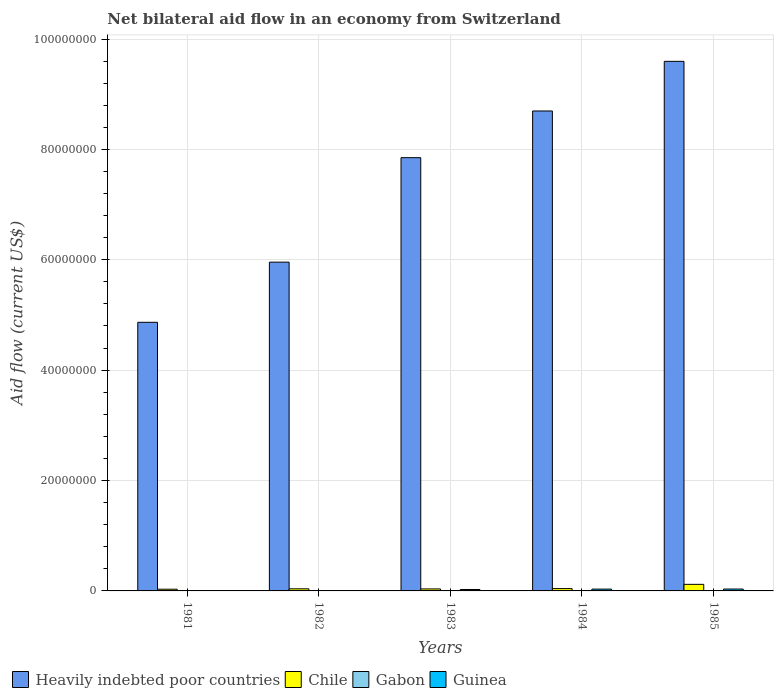How many different coloured bars are there?
Make the answer very short. 4. How many groups of bars are there?
Your answer should be very brief. 5. Are the number of bars on each tick of the X-axis equal?
Make the answer very short. Yes. How many bars are there on the 2nd tick from the left?
Provide a succinct answer. 4. How many bars are there on the 4th tick from the right?
Make the answer very short. 4. What is the label of the 3rd group of bars from the left?
Your answer should be compact. 1983. What is the net bilateral aid flow in Heavily indebted poor countries in 1984?
Give a very brief answer. 8.70e+07. Across all years, what is the maximum net bilateral aid flow in Chile?
Provide a short and direct response. 1.19e+06. Across all years, what is the minimum net bilateral aid flow in Gabon?
Your answer should be very brief. 10000. In which year was the net bilateral aid flow in Heavily indebted poor countries minimum?
Keep it short and to the point. 1981. What is the difference between the net bilateral aid flow in Heavily indebted poor countries in 1984 and that in 1985?
Your answer should be very brief. -8.99e+06. What is the difference between the net bilateral aid flow in Guinea in 1983 and the net bilateral aid flow in Chile in 1985?
Your answer should be very brief. -9.30e+05. What is the average net bilateral aid flow in Guinea per year?
Offer a very short reply. 2.00e+05. In how many years, is the net bilateral aid flow in Guinea greater than 72000000 US$?
Offer a terse response. 0. What is the ratio of the net bilateral aid flow in Guinea in 1982 to that in 1985?
Your answer should be very brief. 0.18. Is the net bilateral aid flow in Heavily indebted poor countries in 1984 less than that in 1985?
Give a very brief answer. Yes. What is the difference between the highest and the second highest net bilateral aid flow in Heavily indebted poor countries?
Give a very brief answer. 8.99e+06. What is the difference between the highest and the lowest net bilateral aid flow in Chile?
Keep it short and to the point. 8.80e+05. In how many years, is the net bilateral aid flow in Gabon greater than the average net bilateral aid flow in Gabon taken over all years?
Your response must be concise. 4. What does the 1st bar from the left in 1981 represents?
Your response must be concise. Heavily indebted poor countries. What does the 4th bar from the right in 1982 represents?
Ensure brevity in your answer.  Heavily indebted poor countries. How many bars are there?
Provide a short and direct response. 20. What is the difference between two consecutive major ticks on the Y-axis?
Ensure brevity in your answer.  2.00e+07. How many legend labels are there?
Offer a very short reply. 4. What is the title of the graph?
Offer a terse response. Net bilateral aid flow in an economy from Switzerland. Does "Estonia" appear as one of the legend labels in the graph?
Keep it short and to the point. No. What is the label or title of the X-axis?
Provide a short and direct response. Years. What is the label or title of the Y-axis?
Keep it short and to the point. Aid flow (current US$). What is the Aid flow (current US$) in Heavily indebted poor countries in 1981?
Provide a succinct answer. 4.87e+07. What is the Aid flow (current US$) in Heavily indebted poor countries in 1982?
Make the answer very short. 5.96e+07. What is the Aid flow (current US$) in Chile in 1982?
Your answer should be very brief. 3.80e+05. What is the Aid flow (current US$) of Heavily indebted poor countries in 1983?
Your answer should be compact. 7.85e+07. What is the Aid flow (current US$) in Chile in 1983?
Your answer should be very brief. 3.60e+05. What is the Aid flow (current US$) of Guinea in 1983?
Offer a very short reply. 2.60e+05. What is the Aid flow (current US$) in Heavily indebted poor countries in 1984?
Provide a short and direct response. 8.70e+07. What is the Aid flow (current US$) in Chile in 1984?
Keep it short and to the point. 4.20e+05. What is the Aid flow (current US$) in Guinea in 1984?
Give a very brief answer. 3.30e+05. What is the Aid flow (current US$) in Heavily indebted poor countries in 1985?
Your answer should be compact. 9.60e+07. What is the Aid flow (current US$) of Chile in 1985?
Ensure brevity in your answer.  1.19e+06. Across all years, what is the maximum Aid flow (current US$) of Heavily indebted poor countries?
Your answer should be very brief. 9.60e+07. Across all years, what is the maximum Aid flow (current US$) of Chile?
Offer a very short reply. 1.19e+06. Across all years, what is the minimum Aid flow (current US$) in Heavily indebted poor countries?
Make the answer very short. 4.87e+07. Across all years, what is the minimum Aid flow (current US$) in Chile?
Offer a very short reply. 3.10e+05. What is the total Aid flow (current US$) in Heavily indebted poor countries in the graph?
Keep it short and to the point. 3.70e+08. What is the total Aid flow (current US$) in Chile in the graph?
Give a very brief answer. 2.66e+06. What is the total Aid flow (current US$) of Guinea in the graph?
Keep it short and to the point. 1.00e+06. What is the difference between the Aid flow (current US$) of Heavily indebted poor countries in 1981 and that in 1982?
Offer a very short reply. -1.09e+07. What is the difference between the Aid flow (current US$) in Gabon in 1981 and that in 1982?
Offer a very short reply. -4.00e+04. What is the difference between the Aid flow (current US$) of Heavily indebted poor countries in 1981 and that in 1983?
Your response must be concise. -2.98e+07. What is the difference between the Aid flow (current US$) of Chile in 1981 and that in 1983?
Make the answer very short. -5.00e+04. What is the difference between the Aid flow (current US$) in Gabon in 1981 and that in 1983?
Offer a terse response. -5.00e+04. What is the difference between the Aid flow (current US$) of Guinea in 1981 and that in 1983?
Ensure brevity in your answer.  -2.50e+05. What is the difference between the Aid flow (current US$) of Heavily indebted poor countries in 1981 and that in 1984?
Your response must be concise. -3.83e+07. What is the difference between the Aid flow (current US$) in Chile in 1981 and that in 1984?
Provide a short and direct response. -1.10e+05. What is the difference between the Aid flow (current US$) in Gabon in 1981 and that in 1984?
Provide a succinct answer. -4.00e+04. What is the difference between the Aid flow (current US$) of Guinea in 1981 and that in 1984?
Offer a terse response. -3.20e+05. What is the difference between the Aid flow (current US$) of Heavily indebted poor countries in 1981 and that in 1985?
Offer a very short reply. -4.73e+07. What is the difference between the Aid flow (current US$) in Chile in 1981 and that in 1985?
Your answer should be compact. -8.80e+05. What is the difference between the Aid flow (current US$) in Guinea in 1981 and that in 1985?
Your answer should be compact. -3.30e+05. What is the difference between the Aid flow (current US$) of Heavily indebted poor countries in 1982 and that in 1983?
Ensure brevity in your answer.  -1.89e+07. What is the difference between the Aid flow (current US$) of Gabon in 1982 and that in 1983?
Provide a succinct answer. -10000. What is the difference between the Aid flow (current US$) of Guinea in 1982 and that in 1983?
Make the answer very short. -2.00e+05. What is the difference between the Aid flow (current US$) in Heavily indebted poor countries in 1982 and that in 1984?
Ensure brevity in your answer.  -2.74e+07. What is the difference between the Aid flow (current US$) of Guinea in 1982 and that in 1984?
Your answer should be compact. -2.70e+05. What is the difference between the Aid flow (current US$) of Heavily indebted poor countries in 1982 and that in 1985?
Provide a short and direct response. -3.64e+07. What is the difference between the Aid flow (current US$) in Chile in 1982 and that in 1985?
Provide a short and direct response. -8.10e+05. What is the difference between the Aid flow (current US$) of Gabon in 1982 and that in 1985?
Ensure brevity in your answer.  -10000. What is the difference between the Aid flow (current US$) of Guinea in 1982 and that in 1985?
Make the answer very short. -2.80e+05. What is the difference between the Aid flow (current US$) of Heavily indebted poor countries in 1983 and that in 1984?
Give a very brief answer. -8.46e+06. What is the difference between the Aid flow (current US$) of Chile in 1983 and that in 1984?
Ensure brevity in your answer.  -6.00e+04. What is the difference between the Aid flow (current US$) in Guinea in 1983 and that in 1984?
Provide a succinct answer. -7.00e+04. What is the difference between the Aid flow (current US$) in Heavily indebted poor countries in 1983 and that in 1985?
Your answer should be very brief. -1.74e+07. What is the difference between the Aid flow (current US$) in Chile in 1983 and that in 1985?
Your answer should be very brief. -8.30e+05. What is the difference between the Aid flow (current US$) of Gabon in 1983 and that in 1985?
Your answer should be very brief. 0. What is the difference between the Aid flow (current US$) in Guinea in 1983 and that in 1985?
Give a very brief answer. -8.00e+04. What is the difference between the Aid flow (current US$) in Heavily indebted poor countries in 1984 and that in 1985?
Give a very brief answer. -8.99e+06. What is the difference between the Aid flow (current US$) in Chile in 1984 and that in 1985?
Provide a succinct answer. -7.70e+05. What is the difference between the Aid flow (current US$) of Gabon in 1984 and that in 1985?
Your answer should be very brief. -10000. What is the difference between the Aid flow (current US$) in Heavily indebted poor countries in 1981 and the Aid flow (current US$) in Chile in 1982?
Your answer should be very brief. 4.83e+07. What is the difference between the Aid flow (current US$) in Heavily indebted poor countries in 1981 and the Aid flow (current US$) in Gabon in 1982?
Offer a terse response. 4.86e+07. What is the difference between the Aid flow (current US$) of Heavily indebted poor countries in 1981 and the Aid flow (current US$) of Guinea in 1982?
Your response must be concise. 4.86e+07. What is the difference between the Aid flow (current US$) of Chile in 1981 and the Aid flow (current US$) of Guinea in 1982?
Offer a very short reply. 2.50e+05. What is the difference between the Aid flow (current US$) of Gabon in 1981 and the Aid flow (current US$) of Guinea in 1982?
Your answer should be very brief. -5.00e+04. What is the difference between the Aid flow (current US$) of Heavily indebted poor countries in 1981 and the Aid flow (current US$) of Chile in 1983?
Your response must be concise. 4.83e+07. What is the difference between the Aid flow (current US$) in Heavily indebted poor countries in 1981 and the Aid flow (current US$) in Gabon in 1983?
Ensure brevity in your answer.  4.86e+07. What is the difference between the Aid flow (current US$) of Heavily indebted poor countries in 1981 and the Aid flow (current US$) of Guinea in 1983?
Give a very brief answer. 4.84e+07. What is the difference between the Aid flow (current US$) of Chile in 1981 and the Aid flow (current US$) of Gabon in 1983?
Your answer should be compact. 2.50e+05. What is the difference between the Aid flow (current US$) of Heavily indebted poor countries in 1981 and the Aid flow (current US$) of Chile in 1984?
Make the answer very short. 4.82e+07. What is the difference between the Aid flow (current US$) in Heavily indebted poor countries in 1981 and the Aid flow (current US$) in Gabon in 1984?
Offer a very short reply. 4.86e+07. What is the difference between the Aid flow (current US$) in Heavily indebted poor countries in 1981 and the Aid flow (current US$) in Guinea in 1984?
Offer a terse response. 4.83e+07. What is the difference between the Aid flow (current US$) of Chile in 1981 and the Aid flow (current US$) of Guinea in 1984?
Give a very brief answer. -2.00e+04. What is the difference between the Aid flow (current US$) in Gabon in 1981 and the Aid flow (current US$) in Guinea in 1984?
Keep it short and to the point. -3.20e+05. What is the difference between the Aid flow (current US$) in Heavily indebted poor countries in 1981 and the Aid flow (current US$) in Chile in 1985?
Your answer should be very brief. 4.75e+07. What is the difference between the Aid flow (current US$) of Heavily indebted poor countries in 1981 and the Aid flow (current US$) of Gabon in 1985?
Offer a very short reply. 4.86e+07. What is the difference between the Aid flow (current US$) in Heavily indebted poor countries in 1981 and the Aid flow (current US$) in Guinea in 1985?
Make the answer very short. 4.83e+07. What is the difference between the Aid flow (current US$) in Gabon in 1981 and the Aid flow (current US$) in Guinea in 1985?
Keep it short and to the point. -3.30e+05. What is the difference between the Aid flow (current US$) of Heavily indebted poor countries in 1982 and the Aid flow (current US$) of Chile in 1983?
Ensure brevity in your answer.  5.92e+07. What is the difference between the Aid flow (current US$) of Heavily indebted poor countries in 1982 and the Aid flow (current US$) of Gabon in 1983?
Keep it short and to the point. 5.95e+07. What is the difference between the Aid flow (current US$) of Heavily indebted poor countries in 1982 and the Aid flow (current US$) of Guinea in 1983?
Offer a very short reply. 5.93e+07. What is the difference between the Aid flow (current US$) of Chile in 1982 and the Aid flow (current US$) of Guinea in 1983?
Provide a short and direct response. 1.20e+05. What is the difference between the Aid flow (current US$) of Gabon in 1982 and the Aid flow (current US$) of Guinea in 1983?
Keep it short and to the point. -2.10e+05. What is the difference between the Aid flow (current US$) in Heavily indebted poor countries in 1982 and the Aid flow (current US$) in Chile in 1984?
Your response must be concise. 5.92e+07. What is the difference between the Aid flow (current US$) of Heavily indebted poor countries in 1982 and the Aid flow (current US$) of Gabon in 1984?
Provide a short and direct response. 5.95e+07. What is the difference between the Aid flow (current US$) of Heavily indebted poor countries in 1982 and the Aid flow (current US$) of Guinea in 1984?
Offer a terse response. 5.92e+07. What is the difference between the Aid flow (current US$) of Chile in 1982 and the Aid flow (current US$) of Guinea in 1984?
Provide a short and direct response. 5.00e+04. What is the difference between the Aid flow (current US$) of Gabon in 1982 and the Aid flow (current US$) of Guinea in 1984?
Keep it short and to the point. -2.80e+05. What is the difference between the Aid flow (current US$) in Heavily indebted poor countries in 1982 and the Aid flow (current US$) in Chile in 1985?
Make the answer very short. 5.84e+07. What is the difference between the Aid flow (current US$) of Heavily indebted poor countries in 1982 and the Aid flow (current US$) of Gabon in 1985?
Make the answer very short. 5.95e+07. What is the difference between the Aid flow (current US$) of Heavily indebted poor countries in 1982 and the Aid flow (current US$) of Guinea in 1985?
Ensure brevity in your answer.  5.92e+07. What is the difference between the Aid flow (current US$) in Chile in 1982 and the Aid flow (current US$) in Guinea in 1985?
Offer a very short reply. 4.00e+04. What is the difference between the Aid flow (current US$) of Heavily indebted poor countries in 1983 and the Aid flow (current US$) of Chile in 1984?
Your answer should be compact. 7.81e+07. What is the difference between the Aid flow (current US$) in Heavily indebted poor countries in 1983 and the Aid flow (current US$) in Gabon in 1984?
Provide a short and direct response. 7.84e+07. What is the difference between the Aid flow (current US$) in Heavily indebted poor countries in 1983 and the Aid flow (current US$) in Guinea in 1984?
Offer a terse response. 7.82e+07. What is the difference between the Aid flow (current US$) of Heavily indebted poor countries in 1983 and the Aid flow (current US$) of Chile in 1985?
Offer a very short reply. 7.73e+07. What is the difference between the Aid flow (current US$) of Heavily indebted poor countries in 1983 and the Aid flow (current US$) of Gabon in 1985?
Ensure brevity in your answer.  7.84e+07. What is the difference between the Aid flow (current US$) in Heavily indebted poor countries in 1983 and the Aid flow (current US$) in Guinea in 1985?
Provide a short and direct response. 7.82e+07. What is the difference between the Aid flow (current US$) in Chile in 1983 and the Aid flow (current US$) in Gabon in 1985?
Provide a succinct answer. 3.00e+05. What is the difference between the Aid flow (current US$) of Gabon in 1983 and the Aid flow (current US$) of Guinea in 1985?
Provide a succinct answer. -2.80e+05. What is the difference between the Aid flow (current US$) in Heavily indebted poor countries in 1984 and the Aid flow (current US$) in Chile in 1985?
Your answer should be compact. 8.58e+07. What is the difference between the Aid flow (current US$) in Heavily indebted poor countries in 1984 and the Aid flow (current US$) in Gabon in 1985?
Offer a very short reply. 8.69e+07. What is the difference between the Aid flow (current US$) of Heavily indebted poor countries in 1984 and the Aid flow (current US$) of Guinea in 1985?
Provide a short and direct response. 8.66e+07. What is the difference between the Aid flow (current US$) of Chile in 1984 and the Aid flow (current US$) of Guinea in 1985?
Your answer should be very brief. 8.00e+04. What is the average Aid flow (current US$) in Heavily indebted poor countries per year?
Keep it short and to the point. 7.39e+07. What is the average Aid flow (current US$) in Chile per year?
Your answer should be compact. 5.32e+05. What is the average Aid flow (current US$) in Gabon per year?
Keep it short and to the point. 4.60e+04. What is the average Aid flow (current US$) in Guinea per year?
Your response must be concise. 2.00e+05. In the year 1981, what is the difference between the Aid flow (current US$) in Heavily indebted poor countries and Aid flow (current US$) in Chile?
Offer a terse response. 4.84e+07. In the year 1981, what is the difference between the Aid flow (current US$) in Heavily indebted poor countries and Aid flow (current US$) in Gabon?
Give a very brief answer. 4.87e+07. In the year 1981, what is the difference between the Aid flow (current US$) of Heavily indebted poor countries and Aid flow (current US$) of Guinea?
Ensure brevity in your answer.  4.87e+07. In the year 1981, what is the difference between the Aid flow (current US$) of Chile and Aid flow (current US$) of Gabon?
Provide a succinct answer. 3.00e+05. In the year 1981, what is the difference between the Aid flow (current US$) in Gabon and Aid flow (current US$) in Guinea?
Give a very brief answer. 0. In the year 1982, what is the difference between the Aid flow (current US$) of Heavily indebted poor countries and Aid flow (current US$) of Chile?
Provide a succinct answer. 5.92e+07. In the year 1982, what is the difference between the Aid flow (current US$) of Heavily indebted poor countries and Aid flow (current US$) of Gabon?
Provide a short and direct response. 5.95e+07. In the year 1982, what is the difference between the Aid flow (current US$) of Heavily indebted poor countries and Aid flow (current US$) of Guinea?
Your answer should be very brief. 5.95e+07. In the year 1982, what is the difference between the Aid flow (current US$) of Gabon and Aid flow (current US$) of Guinea?
Provide a short and direct response. -10000. In the year 1983, what is the difference between the Aid flow (current US$) in Heavily indebted poor countries and Aid flow (current US$) in Chile?
Your answer should be very brief. 7.81e+07. In the year 1983, what is the difference between the Aid flow (current US$) of Heavily indebted poor countries and Aid flow (current US$) of Gabon?
Provide a short and direct response. 7.84e+07. In the year 1983, what is the difference between the Aid flow (current US$) of Heavily indebted poor countries and Aid flow (current US$) of Guinea?
Provide a short and direct response. 7.82e+07. In the year 1983, what is the difference between the Aid flow (current US$) in Chile and Aid flow (current US$) in Guinea?
Your response must be concise. 1.00e+05. In the year 1983, what is the difference between the Aid flow (current US$) in Gabon and Aid flow (current US$) in Guinea?
Give a very brief answer. -2.00e+05. In the year 1984, what is the difference between the Aid flow (current US$) in Heavily indebted poor countries and Aid flow (current US$) in Chile?
Give a very brief answer. 8.65e+07. In the year 1984, what is the difference between the Aid flow (current US$) in Heavily indebted poor countries and Aid flow (current US$) in Gabon?
Make the answer very short. 8.69e+07. In the year 1984, what is the difference between the Aid flow (current US$) in Heavily indebted poor countries and Aid flow (current US$) in Guinea?
Your answer should be compact. 8.66e+07. In the year 1984, what is the difference between the Aid flow (current US$) of Gabon and Aid flow (current US$) of Guinea?
Offer a terse response. -2.80e+05. In the year 1985, what is the difference between the Aid flow (current US$) in Heavily indebted poor countries and Aid flow (current US$) in Chile?
Ensure brevity in your answer.  9.48e+07. In the year 1985, what is the difference between the Aid flow (current US$) in Heavily indebted poor countries and Aid flow (current US$) in Gabon?
Offer a terse response. 9.59e+07. In the year 1985, what is the difference between the Aid flow (current US$) of Heavily indebted poor countries and Aid flow (current US$) of Guinea?
Ensure brevity in your answer.  9.56e+07. In the year 1985, what is the difference between the Aid flow (current US$) of Chile and Aid flow (current US$) of Gabon?
Provide a short and direct response. 1.13e+06. In the year 1985, what is the difference between the Aid flow (current US$) in Chile and Aid flow (current US$) in Guinea?
Provide a short and direct response. 8.50e+05. In the year 1985, what is the difference between the Aid flow (current US$) of Gabon and Aid flow (current US$) of Guinea?
Ensure brevity in your answer.  -2.80e+05. What is the ratio of the Aid flow (current US$) of Heavily indebted poor countries in 1981 to that in 1982?
Give a very brief answer. 0.82. What is the ratio of the Aid flow (current US$) in Chile in 1981 to that in 1982?
Your answer should be compact. 0.82. What is the ratio of the Aid flow (current US$) of Gabon in 1981 to that in 1982?
Keep it short and to the point. 0.2. What is the ratio of the Aid flow (current US$) in Heavily indebted poor countries in 1981 to that in 1983?
Offer a terse response. 0.62. What is the ratio of the Aid flow (current US$) in Chile in 1981 to that in 1983?
Keep it short and to the point. 0.86. What is the ratio of the Aid flow (current US$) of Guinea in 1981 to that in 1983?
Offer a very short reply. 0.04. What is the ratio of the Aid flow (current US$) in Heavily indebted poor countries in 1981 to that in 1984?
Offer a terse response. 0.56. What is the ratio of the Aid flow (current US$) of Chile in 1981 to that in 1984?
Your response must be concise. 0.74. What is the ratio of the Aid flow (current US$) of Guinea in 1981 to that in 1984?
Keep it short and to the point. 0.03. What is the ratio of the Aid flow (current US$) of Heavily indebted poor countries in 1981 to that in 1985?
Provide a short and direct response. 0.51. What is the ratio of the Aid flow (current US$) of Chile in 1981 to that in 1985?
Your response must be concise. 0.26. What is the ratio of the Aid flow (current US$) of Gabon in 1981 to that in 1985?
Make the answer very short. 0.17. What is the ratio of the Aid flow (current US$) of Guinea in 1981 to that in 1985?
Your response must be concise. 0.03. What is the ratio of the Aid flow (current US$) of Heavily indebted poor countries in 1982 to that in 1983?
Provide a succinct answer. 0.76. What is the ratio of the Aid flow (current US$) of Chile in 1982 to that in 1983?
Ensure brevity in your answer.  1.06. What is the ratio of the Aid flow (current US$) of Gabon in 1982 to that in 1983?
Offer a very short reply. 0.83. What is the ratio of the Aid flow (current US$) of Guinea in 1982 to that in 1983?
Your answer should be compact. 0.23. What is the ratio of the Aid flow (current US$) of Heavily indebted poor countries in 1982 to that in 1984?
Provide a succinct answer. 0.69. What is the ratio of the Aid flow (current US$) in Chile in 1982 to that in 1984?
Provide a short and direct response. 0.9. What is the ratio of the Aid flow (current US$) of Gabon in 1982 to that in 1984?
Provide a short and direct response. 1. What is the ratio of the Aid flow (current US$) of Guinea in 1982 to that in 1984?
Make the answer very short. 0.18. What is the ratio of the Aid flow (current US$) in Heavily indebted poor countries in 1982 to that in 1985?
Offer a terse response. 0.62. What is the ratio of the Aid flow (current US$) in Chile in 1982 to that in 1985?
Provide a short and direct response. 0.32. What is the ratio of the Aid flow (current US$) in Gabon in 1982 to that in 1985?
Your answer should be compact. 0.83. What is the ratio of the Aid flow (current US$) of Guinea in 1982 to that in 1985?
Make the answer very short. 0.18. What is the ratio of the Aid flow (current US$) of Heavily indebted poor countries in 1983 to that in 1984?
Provide a succinct answer. 0.9. What is the ratio of the Aid flow (current US$) in Chile in 1983 to that in 1984?
Your answer should be compact. 0.86. What is the ratio of the Aid flow (current US$) of Guinea in 1983 to that in 1984?
Provide a succinct answer. 0.79. What is the ratio of the Aid flow (current US$) in Heavily indebted poor countries in 1983 to that in 1985?
Provide a succinct answer. 0.82. What is the ratio of the Aid flow (current US$) of Chile in 1983 to that in 1985?
Your answer should be very brief. 0.3. What is the ratio of the Aid flow (current US$) of Guinea in 1983 to that in 1985?
Ensure brevity in your answer.  0.76. What is the ratio of the Aid flow (current US$) of Heavily indebted poor countries in 1984 to that in 1985?
Your answer should be compact. 0.91. What is the ratio of the Aid flow (current US$) in Chile in 1984 to that in 1985?
Give a very brief answer. 0.35. What is the ratio of the Aid flow (current US$) in Gabon in 1984 to that in 1985?
Offer a very short reply. 0.83. What is the ratio of the Aid flow (current US$) in Guinea in 1984 to that in 1985?
Keep it short and to the point. 0.97. What is the difference between the highest and the second highest Aid flow (current US$) in Heavily indebted poor countries?
Your answer should be very brief. 8.99e+06. What is the difference between the highest and the second highest Aid flow (current US$) in Chile?
Make the answer very short. 7.70e+05. What is the difference between the highest and the lowest Aid flow (current US$) in Heavily indebted poor countries?
Ensure brevity in your answer.  4.73e+07. What is the difference between the highest and the lowest Aid flow (current US$) in Chile?
Provide a short and direct response. 8.80e+05. What is the difference between the highest and the lowest Aid flow (current US$) of Gabon?
Provide a short and direct response. 5.00e+04. What is the difference between the highest and the lowest Aid flow (current US$) of Guinea?
Offer a very short reply. 3.30e+05. 